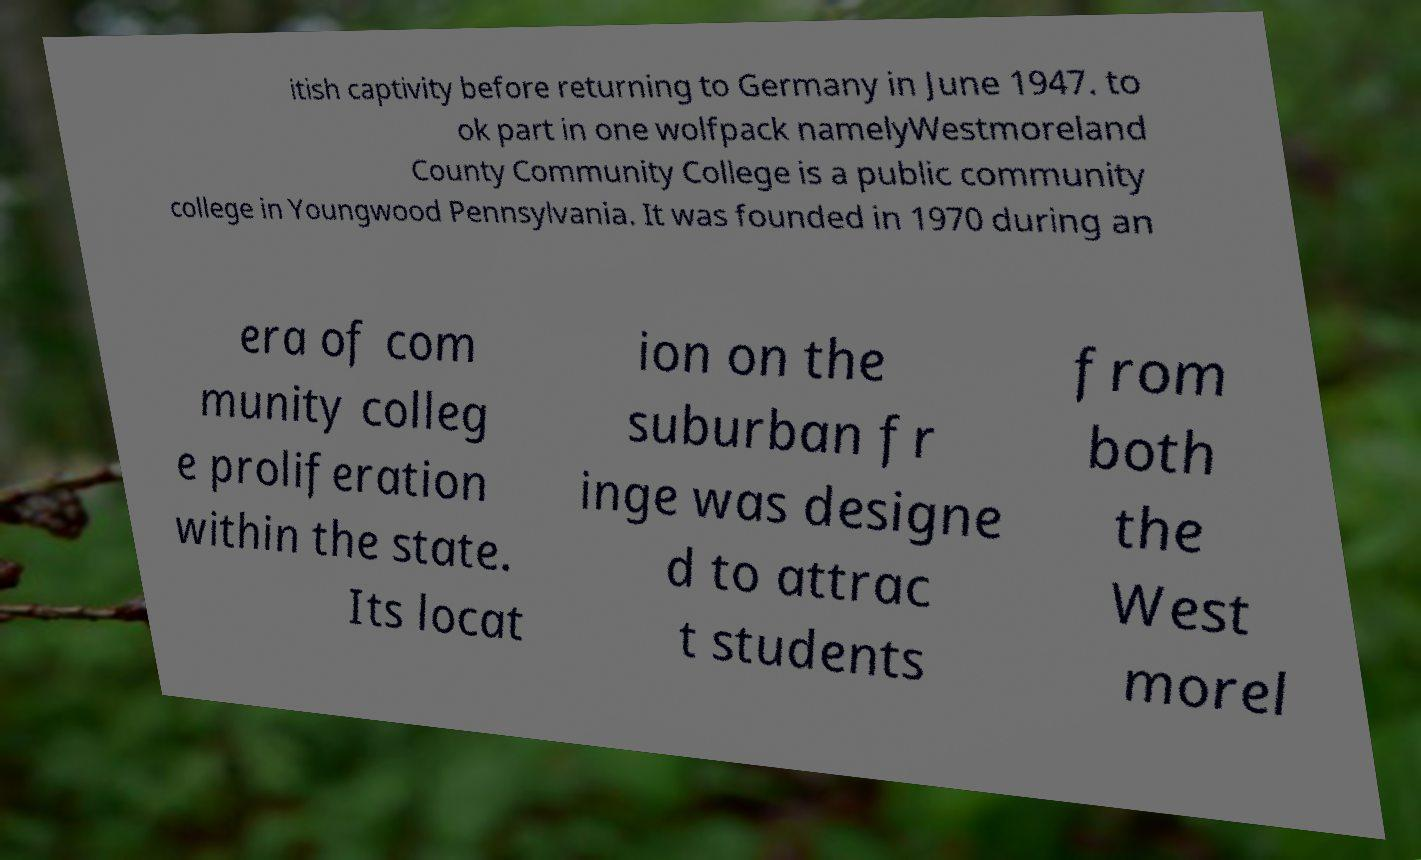There's text embedded in this image that I need extracted. Can you transcribe it verbatim? itish captivity before returning to Germany in June 1947. to ok part in one wolfpack namelyWestmoreland County Community College is a public community college in Youngwood Pennsylvania. It was founded in 1970 during an era of com munity colleg e proliferation within the state. Its locat ion on the suburban fr inge was designe d to attrac t students from both the West morel 